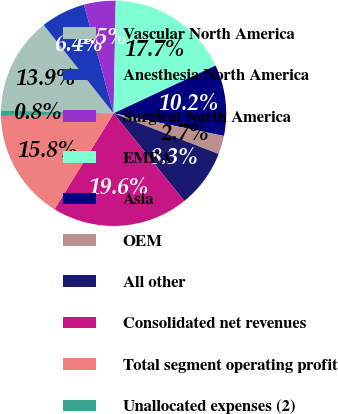Convert chart to OTSL. <chart><loc_0><loc_0><loc_500><loc_500><pie_chart><fcel>Vascular North America<fcel>Anesthesia North America<fcel>Surgical North America<fcel>EMEA<fcel>Asia<fcel>OEM<fcel>All other<fcel>Consolidated net revenues<fcel>Total segment operating profit<fcel>Unallocated expenses (2)<nl><fcel>13.95%<fcel>6.42%<fcel>4.54%<fcel>17.72%<fcel>10.19%<fcel>2.66%<fcel>8.31%<fcel>19.6%<fcel>15.83%<fcel>0.78%<nl></chart> 